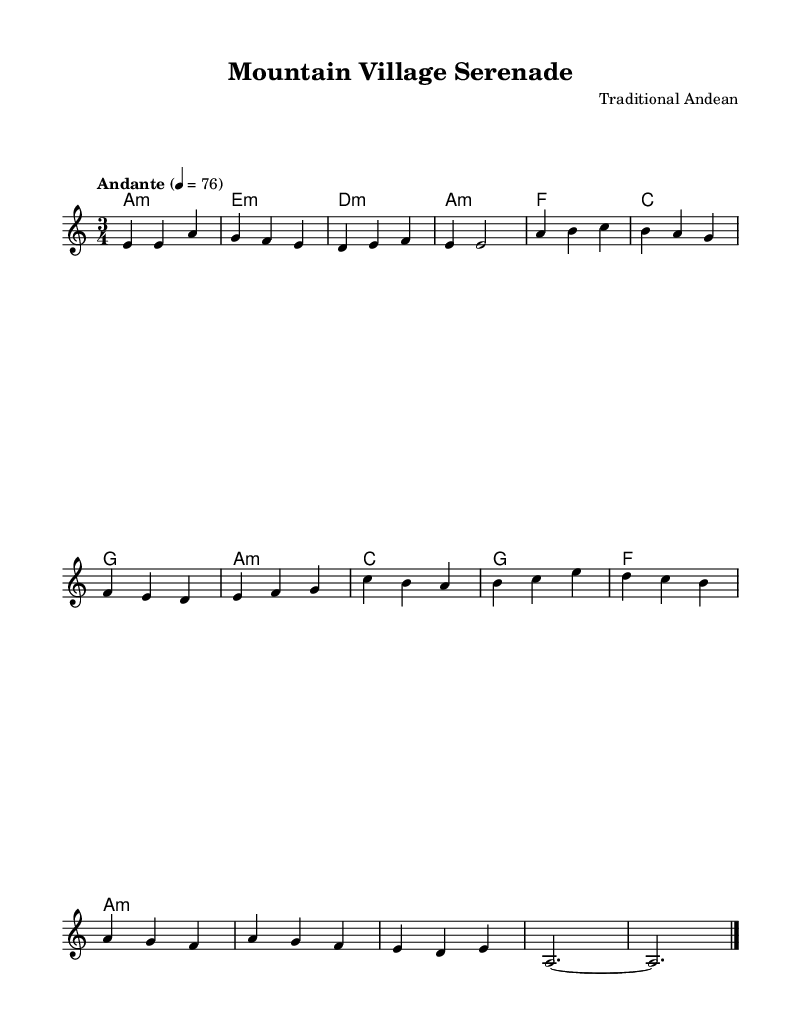What is the key signature of this music? The key signature is indicated by the sharps or flats at the beginning of the staff. In this case, there are no sharps or flats. Hence, the key signature is A minor, which is the relative minor of C major.
Answer: A minor What is the time signature of this music? The time signature is shown at the beginning of the piece, represented as a fraction. Here, the time signature shows three beats per measure, indicated by the 3 over 4.
Answer: 3/4 What is the indicated tempo for this piece? The tempo is typically indicated above the staff. In this case, it reads “Andante” followed by a metronome marking of 76. This signifies a moderate speed.
Answer: Andante 4 = 76 How many measures are in the melody section before the chorus? To find this, count the measures in the melody section up to the point where the chorus starts. The melody section contains four measures total before the chorus.
Answer: 4 What type of musical form does this composition represent? This piece exhibits a simple verse-chorus structure, typical of folkloric ballads, where the verse tells a story and the chorus emphasizes the main theme or emotion.
Answer: Verse-Chorus Which chord is played at the end of the melody? The last note in the melody is an A, and the harmony at that point is also A minor. Thus, the chord is consistent with the final note played, making it A minor.
Answer: A minor What is the significance of the tempo marking "Andante" in this piece? The term "Andante" denotes a moderate pace in music. It informs the performer to play neither too fast nor too slow, reflecting the calmness of village life in the mountains.
Answer: Moderate pace 